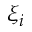<formula> <loc_0><loc_0><loc_500><loc_500>\xi _ { i }</formula> 